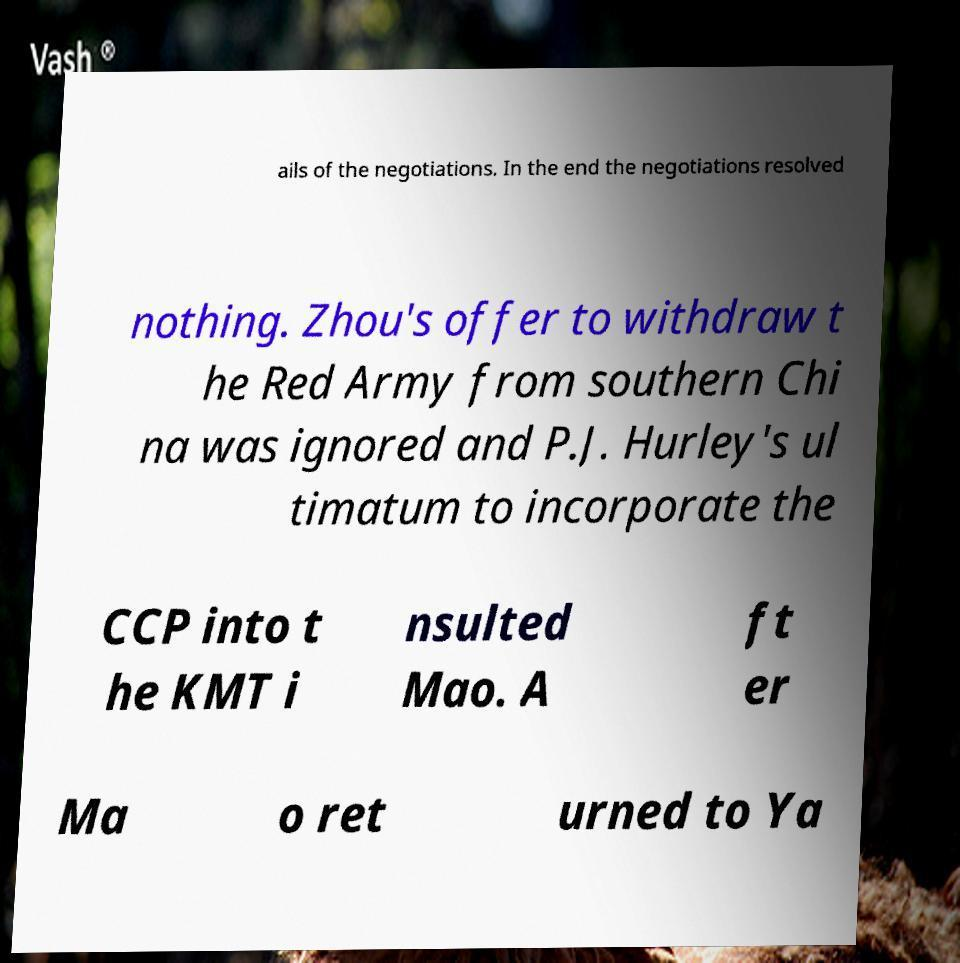I need the written content from this picture converted into text. Can you do that? ails of the negotiations. In the end the negotiations resolved nothing. Zhou's offer to withdraw t he Red Army from southern Chi na was ignored and P.J. Hurley's ul timatum to incorporate the CCP into t he KMT i nsulted Mao. A ft er Ma o ret urned to Ya 